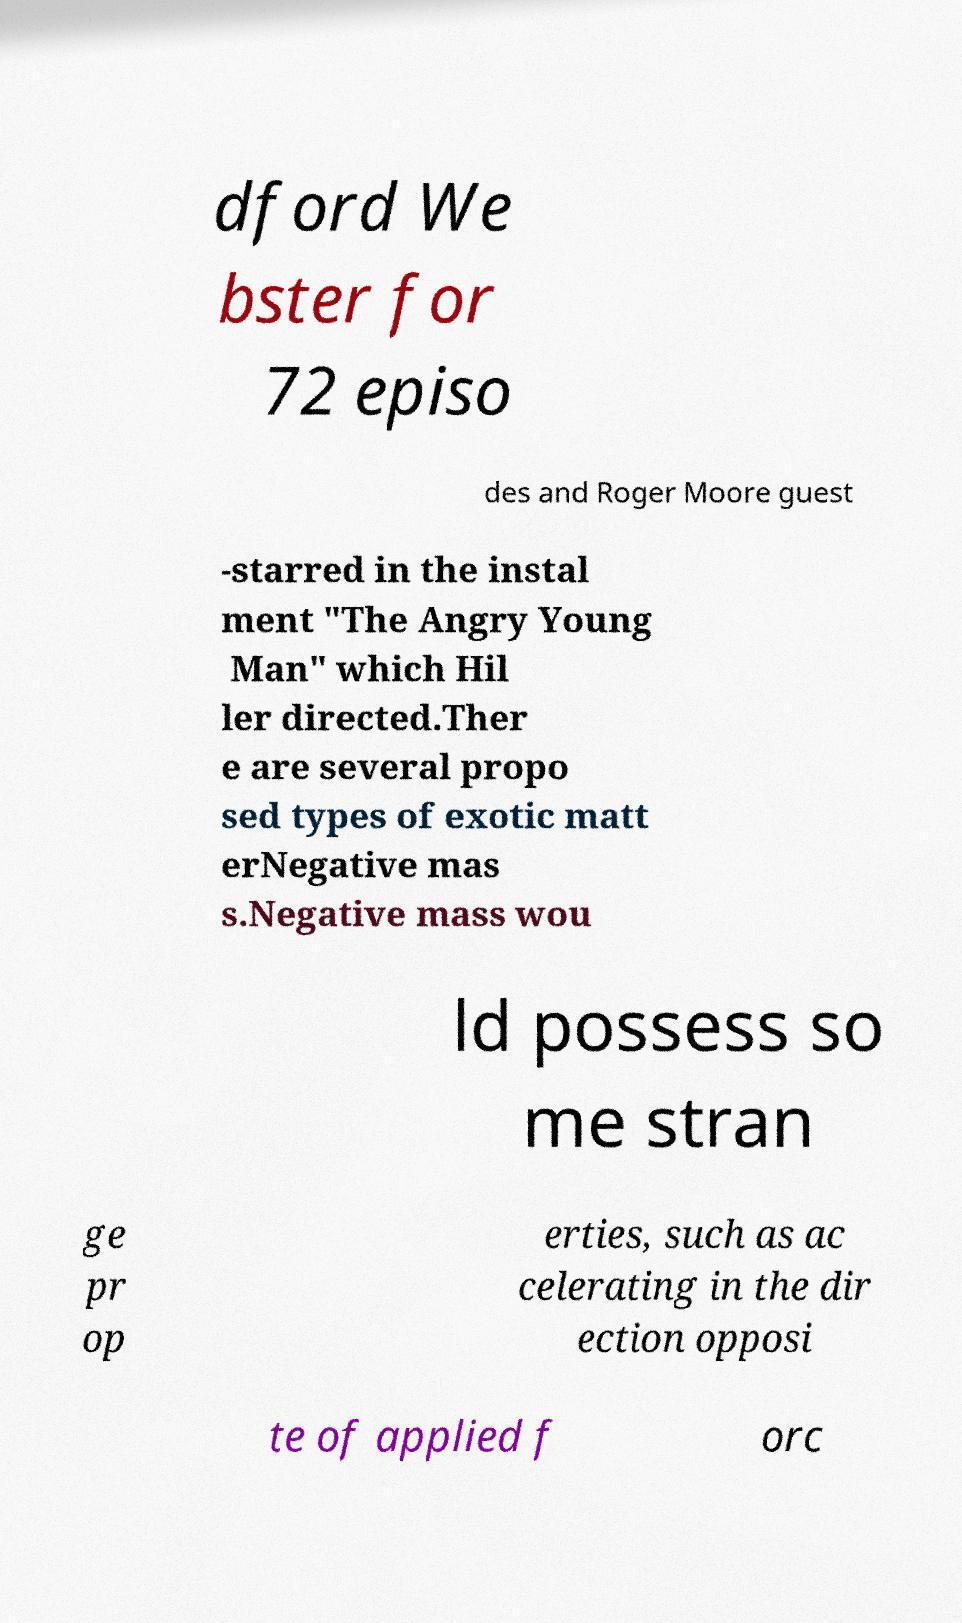Could you assist in decoding the text presented in this image and type it out clearly? dford We bster for 72 episo des and Roger Moore guest -starred in the instal ment "The Angry Young Man" which Hil ler directed.Ther e are several propo sed types of exotic matt erNegative mas s.Negative mass wou ld possess so me stran ge pr op erties, such as ac celerating in the dir ection opposi te of applied f orc 